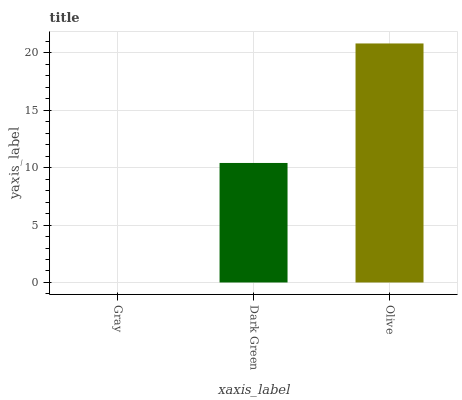Is Gray the minimum?
Answer yes or no. Yes. Is Olive the maximum?
Answer yes or no. Yes. Is Dark Green the minimum?
Answer yes or no. No. Is Dark Green the maximum?
Answer yes or no. No. Is Dark Green greater than Gray?
Answer yes or no. Yes. Is Gray less than Dark Green?
Answer yes or no. Yes. Is Gray greater than Dark Green?
Answer yes or no. No. Is Dark Green less than Gray?
Answer yes or no. No. Is Dark Green the high median?
Answer yes or no. Yes. Is Dark Green the low median?
Answer yes or no. Yes. Is Gray the high median?
Answer yes or no. No. Is Olive the low median?
Answer yes or no. No. 